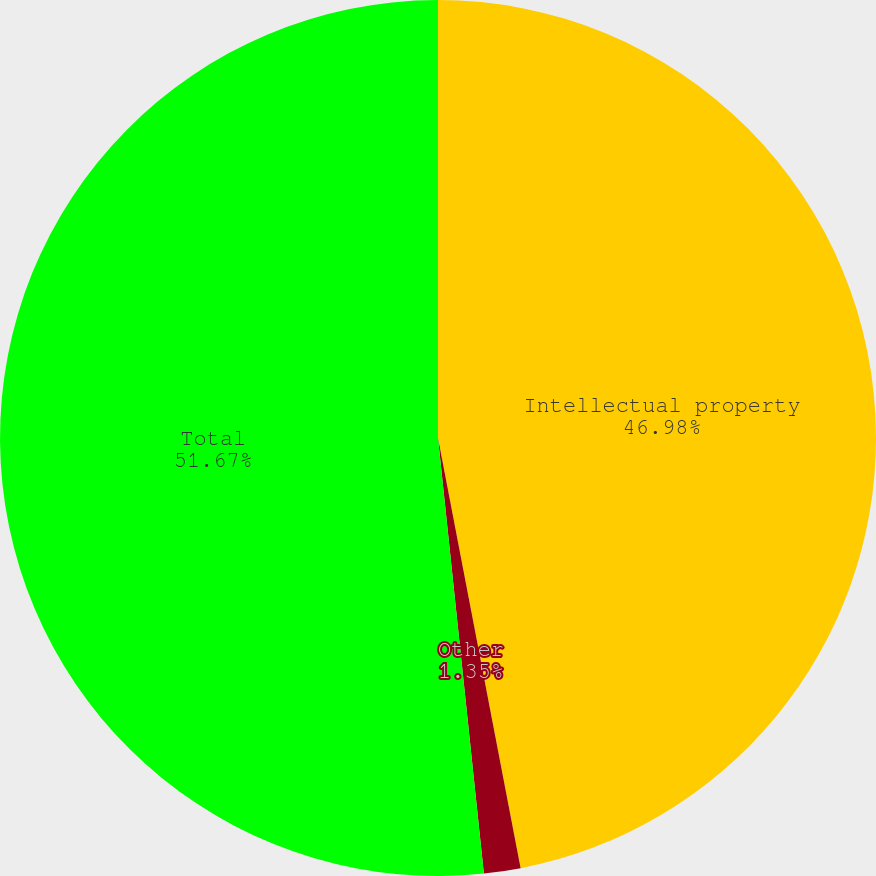Convert chart. <chart><loc_0><loc_0><loc_500><loc_500><pie_chart><fcel>Intellectual property<fcel>Other<fcel>Total<nl><fcel>46.98%<fcel>1.35%<fcel>51.67%<nl></chart> 